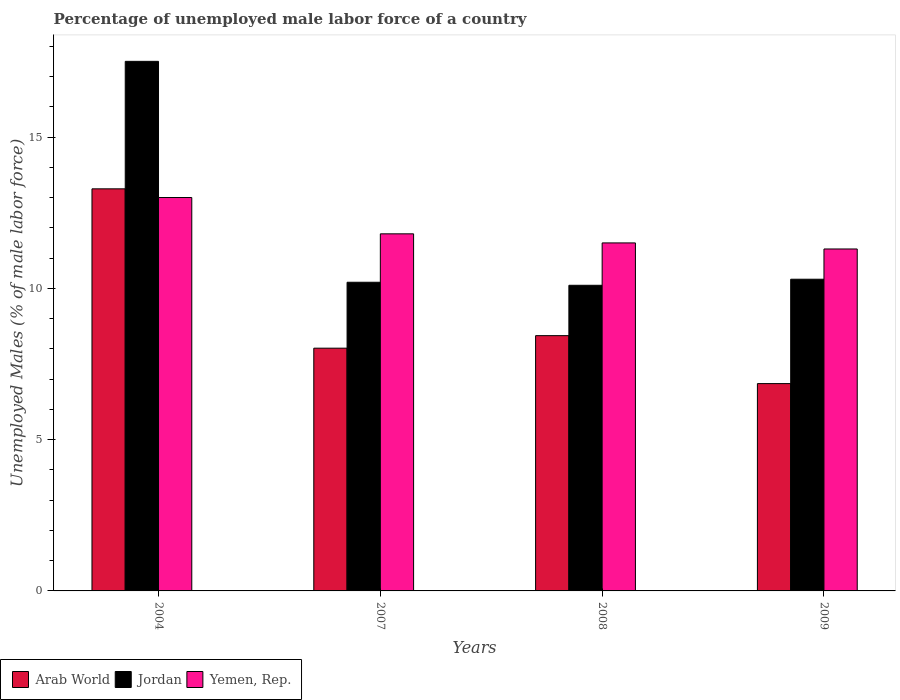How many different coloured bars are there?
Offer a terse response. 3. How many groups of bars are there?
Keep it short and to the point. 4. Are the number of bars per tick equal to the number of legend labels?
Make the answer very short. Yes. Are the number of bars on each tick of the X-axis equal?
Provide a succinct answer. Yes. How many bars are there on the 3rd tick from the right?
Provide a succinct answer. 3. What is the percentage of unemployed male labor force in Yemen, Rep. in 2007?
Give a very brief answer. 11.8. Across all years, what is the maximum percentage of unemployed male labor force in Arab World?
Make the answer very short. 13.29. Across all years, what is the minimum percentage of unemployed male labor force in Yemen, Rep.?
Provide a succinct answer. 11.3. In which year was the percentage of unemployed male labor force in Arab World minimum?
Offer a very short reply. 2009. What is the total percentage of unemployed male labor force in Jordan in the graph?
Your response must be concise. 48.1. What is the difference between the percentage of unemployed male labor force in Arab World in 2007 and that in 2009?
Make the answer very short. 1.17. What is the difference between the percentage of unemployed male labor force in Jordan in 2007 and the percentage of unemployed male labor force in Yemen, Rep. in 2008?
Give a very brief answer. -1.3. What is the average percentage of unemployed male labor force in Yemen, Rep. per year?
Your answer should be very brief. 11.9. In the year 2007, what is the difference between the percentage of unemployed male labor force in Yemen, Rep. and percentage of unemployed male labor force in Jordan?
Your response must be concise. 1.6. What is the ratio of the percentage of unemployed male labor force in Arab World in 2004 to that in 2007?
Keep it short and to the point. 1.66. Is the difference between the percentage of unemployed male labor force in Yemen, Rep. in 2004 and 2007 greater than the difference between the percentage of unemployed male labor force in Jordan in 2004 and 2007?
Your response must be concise. No. What is the difference between the highest and the second highest percentage of unemployed male labor force in Jordan?
Your response must be concise. 7.2. What is the difference between the highest and the lowest percentage of unemployed male labor force in Yemen, Rep.?
Make the answer very short. 1.7. In how many years, is the percentage of unemployed male labor force in Jordan greater than the average percentage of unemployed male labor force in Jordan taken over all years?
Keep it short and to the point. 1. Is the sum of the percentage of unemployed male labor force in Yemen, Rep. in 2004 and 2009 greater than the maximum percentage of unemployed male labor force in Jordan across all years?
Ensure brevity in your answer.  Yes. What does the 2nd bar from the left in 2008 represents?
Make the answer very short. Jordan. What does the 1st bar from the right in 2004 represents?
Your answer should be very brief. Yemen, Rep. Is it the case that in every year, the sum of the percentage of unemployed male labor force in Arab World and percentage of unemployed male labor force in Yemen, Rep. is greater than the percentage of unemployed male labor force in Jordan?
Provide a succinct answer. Yes. Are all the bars in the graph horizontal?
Provide a succinct answer. No. How many years are there in the graph?
Give a very brief answer. 4. Are the values on the major ticks of Y-axis written in scientific E-notation?
Provide a short and direct response. No. Does the graph contain any zero values?
Keep it short and to the point. No. Does the graph contain grids?
Your response must be concise. No. Where does the legend appear in the graph?
Your answer should be compact. Bottom left. How many legend labels are there?
Provide a short and direct response. 3. What is the title of the graph?
Give a very brief answer. Percentage of unemployed male labor force of a country. What is the label or title of the Y-axis?
Offer a terse response. Unemployed Males (% of male labor force). What is the Unemployed Males (% of male labor force) in Arab World in 2004?
Your response must be concise. 13.29. What is the Unemployed Males (% of male labor force) in Arab World in 2007?
Offer a terse response. 8.02. What is the Unemployed Males (% of male labor force) in Jordan in 2007?
Keep it short and to the point. 10.2. What is the Unemployed Males (% of male labor force) in Yemen, Rep. in 2007?
Your response must be concise. 11.8. What is the Unemployed Males (% of male labor force) of Arab World in 2008?
Provide a short and direct response. 8.44. What is the Unemployed Males (% of male labor force) of Jordan in 2008?
Make the answer very short. 10.1. What is the Unemployed Males (% of male labor force) of Arab World in 2009?
Keep it short and to the point. 6.85. What is the Unemployed Males (% of male labor force) of Jordan in 2009?
Ensure brevity in your answer.  10.3. What is the Unemployed Males (% of male labor force) of Yemen, Rep. in 2009?
Your answer should be very brief. 11.3. Across all years, what is the maximum Unemployed Males (% of male labor force) in Arab World?
Your answer should be compact. 13.29. Across all years, what is the maximum Unemployed Males (% of male labor force) of Jordan?
Ensure brevity in your answer.  17.5. Across all years, what is the minimum Unemployed Males (% of male labor force) of Arab World?
Ensure brevity in your answer.  6.85. Across all years, what is the minimum Unemployed Males (% of male labor force) in Jordan?
Keep it short and to the point. 10.1. Across all years, what is the minimum Unemployed Males (% of male labor force) of Yemen, Rep.?
Offer a terse response. 11.3. What is the total Unemployed Males (% of male labor force) in Arab World in the graph?
Ensure brevity in your answer.  36.6. What is the total Unemployed Males (% of male labor force) of Jordan in the graph?
Your response must be concise. 48.1. What is the total Unemployed Males (% of male labor force) of Yemen, Rep. in the graph?
Ensure brevity in your answer.  47.6. What is the difference between the Unemployed Males (% of male labor force) in Arab World in 2004 and that in 2007?
Provide a succinct answer. 5.27. What is the difference between the Unemployed Males (% of male labor force) in Jordan in 2004 and that in 2007?
Offer a very short reply. 7.3. What is the difference between the Unemployed Males (% of male labor force) of Yemen, Rep. in 2004 and that in 2007?
Make the answer very short. 1.2. What is the difference between the Unemployed Males (% of male labor force) of Arab World in 2004 and that in 2008?
Ensure brevity in your answer.  4.85. What is the difference between the Unemployed Males (% of male labor force) of Jordan in 2004 and that in 2008?
Offer a terse response. 7.4. What is the difference between the Unemployed Males (% of male labor force) of Arab World in 2004 and that in 2009?
Your answer should be compact. 6.44. What is the difference between the Unemployed Males (% of male labor force) in Jordan in 2004 and that in 2009?
Provide a succinct answer. 7.2. What is the difference between the Unemployed Males (% of male labor force) of Yemen, Rep. in 2004 and that in 2009?
Offer a terse response. 1.7. What is the difference between the Unemployed Males (% of male labor force) of Arab World in 2007 and that in 2008?
Your response must be concise. -0.41. What is the difference between the Unemployed Males (% of male labor force) in Yemen, Rep. in 2007 and that in 2008?
Give a very brief answer. 0.3. What is the difference between the Unemployed Males (% of male labor force) of Arab World in 2007 and that in 2009?
Offer a very short reply. 1.17. What is the difference between the Unemployed Males (% of male labor force) in Arab World in 2008 and that in 2009?
Your answer should be very brief. 1.58. What is the difference between the Unemployed Males (% of male labor force) in Jordan in 2008 and that in 2009?
Provide a succinct answer. -0.2. What is the difference between the Unemployed Males (% of male labor force) of Yemen, Rep. in 2008 and that in 2009?
Your response must be concise. 0.2. What is the difference between the Unemployed Males (% of male labor force) in Arab World in 2004 and the Unemployed Males (% of male labor force) in Jordan in 2007?
Give a very brief answer. 3.09. What is the difference between the Unemployed Males (% of male labor force) of Arab World in 2004 and the Unemployed Males (% of male labor force) of Yemen, Rep. in 2007?
Your answer should be compact. 1.49. What is the difference between the Unemployed Males (% of male labor force) in Arab World in 2004 and the Unemployed Males (% of male labor force) in Jordan in 2008?
Offer a terse response. 3.19. What is the difference between the Unemployed Males (% of male labor force) in Arab World in 2004 and the Unemployed Males (% of male labor force) in Yemen, Rep. in 2008?
Your answer should be compact. 1.79. What is the difference between the Unemployed Males (% of male labor force) of Arab World in 2004 and the Unemployed Males (% of male labor force) of Jordan in 2009?
Make the answer very short. 2.99. What is the difference between the Unemployed Males (% of male labor force) of Arab World in 2004 and the Unemployed Males (% of male labor force) of Yemen, Rep. in 2009?
Offer a terse response. 1.99. What is the difference between the Unemployed Males (% of male labor force) of Arab World in 2007 and the Unemployed Males (% of male labor force) of Jordan in 2008?
Your response must be concise. -2.08. What is the difference between the Unemployed Males (% of male labor force) of Arab World in 2007 and the Unemployed Males (% of male labor force) of Yemen, Rep. in 2008?
Make the answer very short. -3.48. What is the difference between the Unemployed Males (% of male labor force) of Arab World in 2007 and the Unemployed Males (% of male labor force) of Jordan in 2009?
Keep it short and to the point. -2.28. What is the difference between the Unemployed Males (% of male labor force) of Arab World in 2007 and the Unemployed Males (% of male labor force) of Yemen, Rep. in 2009?
Keep it short and to the point. -3.28. What is the difference between the Unemployed Males (% of male labor force) in Arab World in 2008 and the Unemployed Males (% of male labor force) in Jordan in 2009?
Ensure brevity in your answer.  -1.86. What is the difference between the Unemployed Males (% of male labor force) of Arab World in 2008 and the Unemployed Males (% of male labor force) of Yemen, Rep. in 2009?
Keep it short and to the point. -2.86. What is the average Unemployed Males (% of male labor force) in Arab World per year?
Provide a succinct answer. 9.15. What is the average Unemployed Males (% of male labor force) in Jordan per year?
Offer a very short reply. 12.03. What is the average Unemployed Males (% of male labor force) of Yemen, Rep. per year?
Ensure brevity in your answer.  11.9. In the year 2004, what is the difference between the Unemployed Males (% of male labor force) in Arab World and Unemployed Males (% of male labor force) in Jordan?
Provide a succinct answer. -4.21. In the year 2004, what is the difference between the Unemployed Males (% of male labor force) in Arab World and Unemployed Males (% of male labor force) in Yemen, Rep.?
Keep it short and to the point. 0.29. In the year 2007, what is the difference between the Unemployed Males (% of male labor force) of Arab World and Unemployed Males (% of male labor force) of Jordan?
Offer a terse response. -2.18. In the year 2007, what is the difference between the Unemployed Males (% of male labor force) of Arab World and Unemployed Males (% of male labor force) of Yemen, Rep.?
Provide a short and direct response. -3.78. In the year 2007, what is the difference between the Unemployed Males (% of male labor force) in Jordan and Unemployed Males (% of male labor force) in Yemen, Rep.?
Offer a very short reply. -1.6. In the year 2008, what is the difference between the Unemployed Males (% of male labor force) of Arab World and Unemployed Males (% of male labor force) of Jordan?
Offer a terse response. -1.66. In the year 2008, what is the difference between the Unemployed Males (% of male labor force) of Arab World and Unemployed Males (% of male labor force) of Yemen, Rep.?
Offer a very short reply. -3.06. In the year 2009, what is the difference between the Unemployed Males (% of male labor force) of Arab World and Unemployed Males (% of male labor force) of Jordan?
Give a very brief answer. -3.45. In the year 2009, what is the difference between the Unemployed Males (% of male labor force) in Arab World and Unemployed Males (% of male labor force) in Yemen, Rep.?
Your response must be concise. -4.45. In the year 2009, what is the difference between the Unemployed Males (% of male labor force) in Jordan and Unemployed Males (% of male labor force) in Yemen, Rep.?
Offer a very short reply. -1. What is the ratio of the Unemployed Males (% of male labor force) in Arab World in 2004 to that in 2007?
Offer a very short reply. 1.66. What is the ratio of the Unemployed Males (% of male labor force) of Jordan in 2004 to that in 2007?
Provide a short and direct response. 1.72. What is the ratio of the Unemployed Males (% of male labor force) of Yemen, Rep. in 2004 to that in 2007?
Ensure brevity in your answer.  1.1. What is the ratio of the Unemployed Males (% of male labor force) in Arab World in 2004 to that in 2008?
Provide a succinct answer. 1.58. What is the ratio of the Unemployed Males (% of male labor force) of Jordan in 2004 to that in 2008?
Your answer should be compact. 1.73. What is the ratio of the Unemployed Males (% of male labor force) of Yemen, Rep. in 2004 to that in 2008?
Offer a terse response. 1.13. What is the ratio of the Unemployed Males (% of male labor force) in Arab World in 2004 to that in 2009?
Your answer should be very brief. 1.94. What is the ratio of the Unemployed Males (% of male labor force) in Jordan in 2004 to that in 2009?
Keep it short and to the point. 1.7. What is the ratio of the Unemployed Males (% of male labor force) in Yemen, Rep. in 2004 to that in 2009?
Your answer should be very brief. 1.15. What is the ratio of the Unemployed Males (% of male labor force) of Arab World in 2007 to that in 2008?
Make the answer very short. 0.95. What is the ratio of the Unemployed Males (% of male labor force) in Jordan in 2007 to that in 2008?
Provide a succinct answer. 1.01. What is the ratio of the Unemployed Males (% of male labor force) in Yemen, Rep. in 2007 to that in 2008?
Your answer should be very brief. 1.03. What is the ratio of the Unemployed Males (% of male labor force) of Arab World in 2007 to that in 2009?
Offer a very short reply. 1.17. What is the ratio of the Unemployed Males (% of male labor force) of Jordan in 2007 to that in 2009?
Make the answer very short. 0.99. What is the ratio of the Unemployed Males (% of male labor force) in Yemen, Rep. in 2007 to that in 2009?
Your answer should be compact. 1.04. What is the ratio of the Unemployed Males (% of male labor force) of Arab World in 2008 to that in 2009?
Offer a very short reply. 1.23. What is the ratio of the Unemployed Males (% of male labor force) in Jordan in 2008 to that in 2009?
Make the answer very short. 0.98. What is the ratio of the Unemployed Males (% of male labor force) in Yemen, Rep. in 2008 to that in 2009?
Offer a terse response. 1.02. What is the difference between the highest and the second highest Unemployed Males (% of male labor force) of Arab World?
Your answer should be very brief. 4.85. What is the difference between the highest and the second highest Unemployed Males (% of male labor force) in Jordan?
Offer a terse response. 7.2. What is the difference between the highest and the second highest Unemployed Males (% of male labor force) of Yemen, Rep.?
Offer a terse response. 1.2. What is the difference between the highest and the lowest Unemployed Males (% of male labor force) in Arab World?
Make the answer very short. 6.44. What is the difference between the highest and the lowest Unemployed Males (% of male labor force) in Yemen, Rep.?
Your response must be concise. 1.7. 